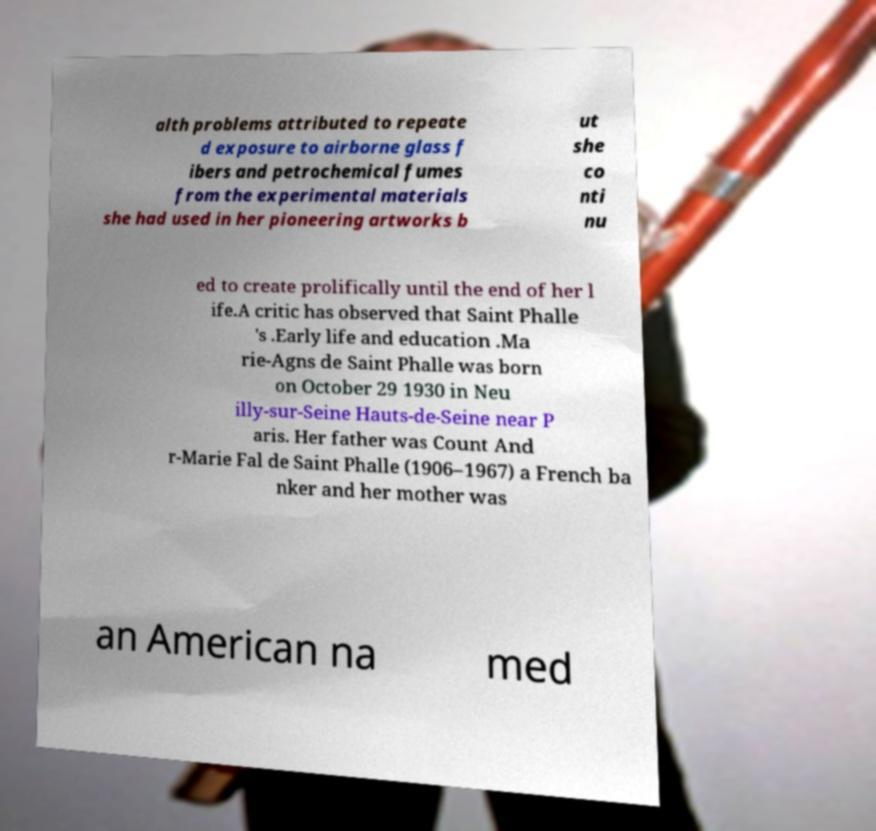Please read and relay the text visible in this image. What does it say? alth problems attributed to repeate d exposure to airborne glass f ibers and petrochemical fumes from the experimental materials she had used in her pioneering artworks b ut she co nti nu ed to create prolifically until the end of her l ife.A critic has observed that Saint Phalle 's .Early life and education .Ma rie-Agns de Saint Phalle was born on October 29 1930 in Neu illy-sur-Seine Hauts-de-Seine near P aris. Her father was Count And r-Marie Fal de Saint Phalle (1906–1967) a French ba nker and her mother was an American na med 